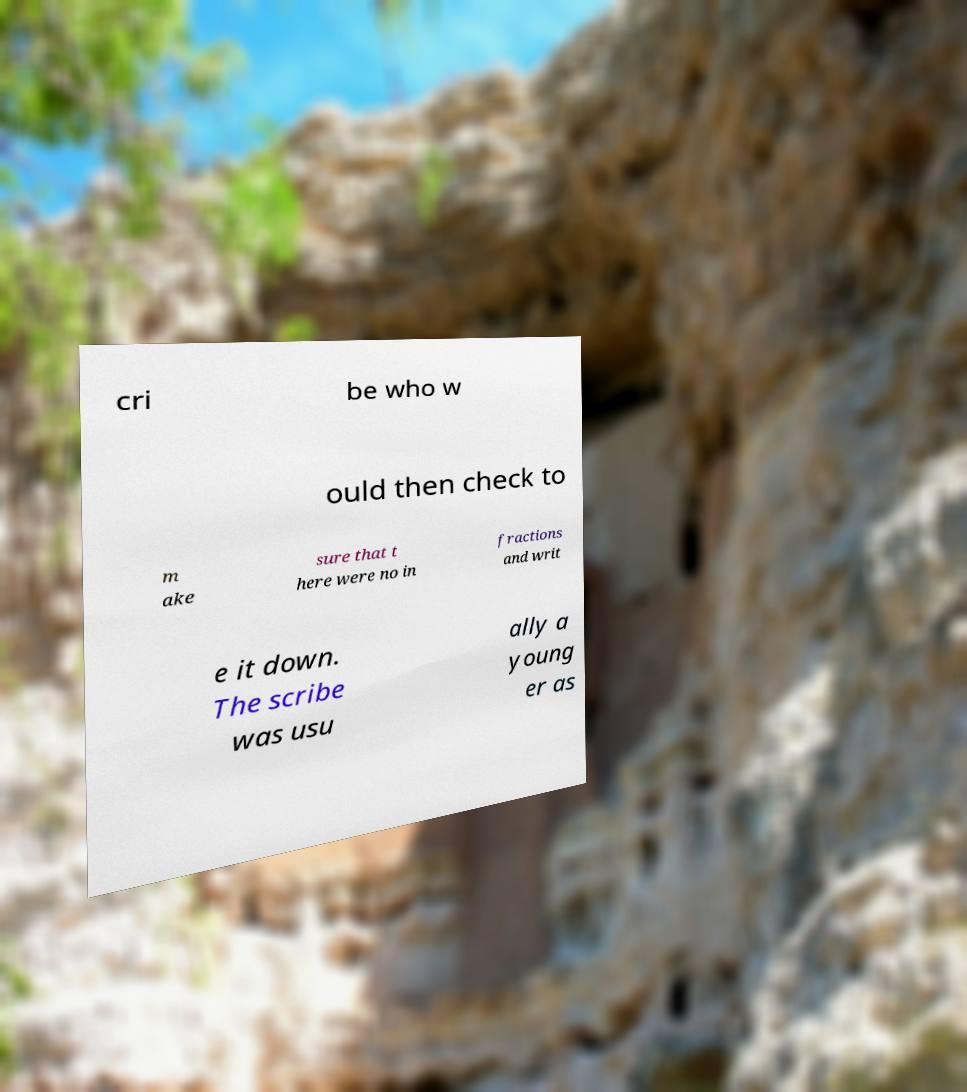Please read and relay the text visible in this image. What does it say? cri be who w ould then check to m ake sure that t here were no in fractions and writ e it down. The scribe was usu ally a young er as 